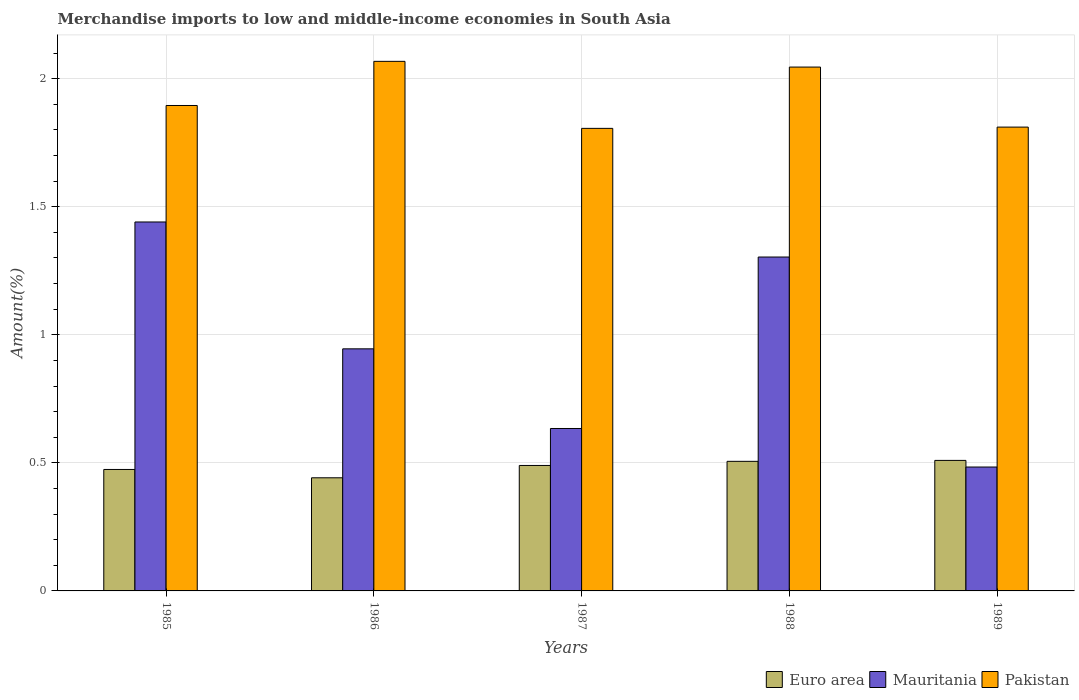How many groups of bars are there?
Make the answer very short. 5. Are the number of bars per tick equal to the number of legend labels?
Your response must be concise. Yes. Are the number of bars on each tick of the X-axis equal?
Keep it short and to the point. Yes. How many bars are there on the 5th tick from the left?
Provide a succinct answer. 3. How many bars are there on the 4th tick from the right?
Make the answer very short. 3. What is the label of the 1st group of bars from the left?
Your answer should be very brief. 1985. What is the percentage of amount earned from merchandise imports in Euro area in 1988?
Your answer should be very brief. 0.51. Across all years, what is the maximum percentage of amount earned from merchandise imports in Mauritania?
Offer a terse response. 1.44. Across all years, what is the minimum percentage of amount earned from merchandise imports in Euro area?
Ensure brevity in your answer.  0.44. In which year was the percentage of amount earned from merchandise imports in Mauritania minimum?
Provide a short and direct response. 1989. What is the total percentage of amount earned from merchandise imports in Euro area in the graph?
Provide a succinct answer. 2.42. What is the difference between the percentage of amount earned from merchandise imports in Mauritania in 1985 and that in 1986?
Your response must be concise. 0.5. What is the difference between the percentage of amount earned from merchandise imports in Pakistan in 1987 and the percentage of amount earned from merchandise imports in Mauritania in 1989?
Keep it short and to the point. 1.32. What is the average percentage of amount earned from merchandise imports in Pakistan per year?
Offer a very short reply. 1.93. In the year 1985, what is the difference between the percentage of amount earned from merchandise imports in Euro area and percentage of amount earned from merchandise imports in Mauritania?
Your answer should be very brief. -0.97. What is the ratio of the percentage of amount earned from merchandise imports in Pakistan in 1988 to that in 1989?
Offer a terse response. 1.13. What is the difference between the highest and the second highest percentage of amount earned from merchandise imports in Mauritania?
Provide a short and direct response. 0.14. What is the difference between the highest and the lowest percentage of amount earned from merchandise imports in Euro area?
Offer a very short reply. 0.07. What does the 3rd bar from the left in 1988 represents?
Ensure brevity in your answer.  Pakistan. Is it the case that in every year, the sum of the percentage of amount earned from merchandise imports in Euro area and percentage of amount earned from merchandise imports in Mauritania is greater than the percentage of amount earned from merchandise imports in Pakistan?
Offer a terse response. No. How many bars are there?
Your answer should be compact. 15. What is the difference between two consecutive major ticks on the Y-axis?
Give a very brief answer. 0.5. Are the values on the major ticks of Y-axis written in scientific E-notation?
Offer a terse response. No. Does the graph contain grids?
Your response must be concise. Yes. How are the legend labels stacked?
Keep it short and to the point. Horizontal. What is the title of the graph?
Provide a short and direct response. Merchandise imports to low and middle-income economies in South Asia. What is the label or title of the X-axis?
Your response must be concise. Years. What is the label or title of the Y-axis?
Provide a short and direct response. Amount(%). What is the Amount(%) of Euro area in 1985?
Keep it short and to the point. 0.47. What is the Amount(%) of Mauritania in 1985?
Provide a succinct answer. 1.44. What is the Amount(%) of Pakistan in 1985?
Keep it short and to the point. 1.9. What is the Amount(%) in Euro area in 1986?
Your answer should be compact. 0.44. What is the Amount(%) in Mauritania in 1986?
Keep it short and to the point. 0.95. What is the Amount(%) in Pakistan in 1986?
Offer a very short reply. 2.07. What is the Amount(%) of Euro area in 1987?
Provide a short and direct response. 0.49. What is the Amount(%) in Mauritania in 1987?
Your answer should be very brief. 0.63. What is the Amount(%) of Pakistan in 1987?
Offer a very short reply. 1.81. What is the Amount(%) of Euro area in 1988?
Make the answer very short. 0.51. What is the Amount(%) in Mauritania in 1988?
Your answer should be very brief. 1.3. What is the Amount(%) of Pakistan in 1988?
Provide a short and direct response. 2.05. What is the Amount(%) of Euro area in 1989?
Your answer should be very brief. 0.51. What is the Amount(%) of Mauritania in 1989?
Ensure brevity in your answer.  0.48. What is the Amount(%) in Pakistan in 1989?
Your answer should be very brief. 1.81. Across all years, what is the maximum Amount(%) in Euro area?
Offer a very short reply. 0.51. Across all years, what is the maximum Amount(%) in Mauritania?
Give a very brief answer. 1.44. Across all years, what is the maximum Amount(%) in Pakistan?
Give a very brief answer. 2.07. Across all years, what is the minimum Amount(%) in Euro area?
Your answer should be very brief. 0.44. Across all years, what is the minimum Amount(%) of Mauritania?
Offer a very short reply. 0.48. Across all years, what is the minimum Amount(%) of Pakistan?
Offer a very short reply. 1.81. What is the total Amount(%) of Euro area in the graph?
Give a very brief answer. 2.42. What is the total Amount(%) in Mauritania in the graph?
Offer a very short reply. 4.81. What is the total Amount(%) in Pakistan in the graph?
Keep it short and to the point. 9.63. What is the difference between the Amount(%) of Euro area in 1985 and that in 1986?
Provide a succinct answer. 0.03. What is the difference between the Amount(%) in Mauritania in 1985 and that in 1986?
Your answer should be compact. 0.5. What is the difference between the Amount(%) in Pakistan in 1985 and that in 1986?
Make the answer very short. -0.17. What is the difference between the Amount(%) in Euro area in 1985 and that in 1987?
Provide a short and direct response. -0.02. What is the difference between the Amount(%) of Mauritania in 1985 and that in 1987?
Offer a terse response. 0.81. What is the difference between the Amount(%) in Pakistan in 1985 and that in 1987?
Your answer should be very brief. 0.09. What is the difference between the Amount(%) in Euro area in 1985 and that in 1988?
Keep it short and to the point. -0.03. What is the difference between the Amount(%) of Mauritania in 1985 and that in 1988?
Provide a short and direct response. 0.14. What is the difference between the Amount(%) of Euro area in 1985 and that in 1989?
Offer a very short reply. -0.04. What is the difference between the Amount(%) of Mauritania in 1985 and that in 1989?
Make the answer very short. 0.96. What is the difference between the Amount(%) in Pakistan in 1985 and that in 1989?
Your answer should be very brief. 0.08. What is the difference between the Amount(%) of Euro area in 1986 and that in 1987?
Give a very brief answer. -0.05. What is the difference between the Amount(%) in Mauritania in 1986 and that in 1987?
Keep it short and to the point. 0.31. What is the difference between the Amount(%) of Pakistan in 1986 and that in 1987?
Provide a succinct answer. 0.26. What is the difference between the Amount(%) of Euro area in 1986 and that in 1988?
Provide a succinct answer. -0.06. What is the difference between the Amount(%) of Mauritania in 1986 and that in 1988?
Give a very brief answer. -0.36. What is the difference between the Amount(%) in Pakistan in 1986 and that in 1988?
Keep it short and to the point. 0.02. What is the difference between the Amount(%) in Euro area in 1986 and that in 1989?
Offer a very short reply. -0.07. What is the difference between the Amount(%) of Mauritania in 1986 and that in 1989?
Ensure brevity in your answer.  0.46. What is the difference between the Amount(%) of Pakistan in 1986 and that in 1989?
Keep it short and to the point. 0.26. What is the difference between the Amount(%) of Euro area in 1987 and that in 1988?
Provide a succinct answer. -0.02. What is the difference between the Amount(%) in Mauritania in 1987 and that in 1988?
Keep it short and to the point. -0.67. What is the difference between the Amount(%) of Pakistan in 1987 and that in 1988?
Give a very brief answer. -0.24. What is the difference between the Amount(%) in Euro area in 1987 and that in 1989?
Keep it short and to the point. -0.02. What is the difference between the Amount(%) in Mauritania in 1987 and that in 1989?
Your answer should be compact. 0.15. What is the difference between the Amount(%) in Pakistan in 1987 and that in 1989?
Ensure brevity in your answer.  -0. What is the difference between the Amount(%) in Euro area in 1988 and that in 1989?
Offer a very short reply. -0. What is the difference between the Amount(%) in Mauritania in 1988 and that in 1989?
Your answer should be very brief. 0.82. What is the difference between the Amount(%) in Pakistan in 1988 and that in 1989?
Your answer should be compact. 0.23. What is the difference between the Amount(%) of Euro area in 1985 and the Amount(%) of Mauritania in 1986?
Ensure brevity in your answer.  -0.47. What is the difference between the Amount(%) in Euro area in 1985 and the Amount(%) in Pakistan in 1986?
Keep it short and to the point. -1.59. What is the difference between the Amount(%) in Mauritania in 1985 and the Amount(%) in Pakistan in 1986?
Offer a very short reply. -0.63. What is the difference between the Amount(%) in Euro area in 1985 and the Amount(%) in Mauritania in 1987?
Offer a terse response. -0.16. What is the difference between the Amount(%) of Euro area in 1985 and the Amount(%) of Pakistan in 1987?
Give a very brief answer. -1.33. What is the difference between the Amount(%) in Mauritania in 1985 and the Amount(%) in Pakistan in 1987?
Make the answer very short. -0.37. What is the difference between the Amount(%) of Euro area in 1985 and the Amount(%) of Mauritania in 1988?
Your response must be concise. -0.83. What is the difference between the Amount(%) in Euro area in 1985 and the Amount(%) in Pakistan in 1988?
Give a very brief answer. -1.57. What is the difference between the Amount(%) in Mauritania in 1985 and the Amount(%) in Pakistan in 1988?
Provide a succinct answer. -0.6. What is the difference between the Amount(%) in Euro area in 1985 and the Amount(%) in Mauritania in 1989?
Give a very brief answer. -0.01. What is the difference between the Amount(%) of Euro area in 1985 and the Amount(%) of Pakistan in 1989?
Offer a very short reply. -1.34. What is the difference between the Amount(%) of Mauritania in 1985 and the Amount(%) of Pakistan in 1989?
Make the answer very short. -0.37. What is the difference between the Amount(%) of Euro area in 1986 and the Amount(%) of Mauritania in 1987?
Ensure brevity in your answer.  -0.19. What is the difference between the Amount(%) in Euro area in 1986 and the Amount(%) in Pakistan in 1987?
Keep it short and to the point. -1.36. What is the difference between the Amount(%) of Mauritania in 1986 and the Amount(%) of Pakistan in 1987?
Keep it short and to the point. -0.86. What is the difference between the Amount(%) in Euro area in 1986 and the Amount(%) in Mauritania in 1988?
Offer a terse response. -0.86. What is the difference between the Amount(%) in Euro area in 1986 and the Amount(%) in Pakistan in 1988?
Make the answer very short. -1.6. What is the difference between the Amount(%) of Mauritania in 1986 and the Amount(%) of Pakistan in 1988?
Make the answer very short. -1.1. What is the difference between the Amount(%) in Euro area in 1986 and the Amount(%) in Mauritania in 1989?
Provide a succinct answer. -0.04. What is the difference between the Amount(%) in Euro area in 1986 and the Amount(%) in Pakistan in 1989?
Provide a short and direct response. -1.37. What is the difference between the Amount(%) of Mauritania in 1986 and the Amount(%) of Pakistan in 1989?
Your answer should be compact. -0.87. What is the difference between the Amount(%) of Euro area in 1987 and the Amount(%) of Mauritania in 1988?
Ensure brevity in your answer.  -0.81. What is the difference between the Amount(%) in Euro area in 1987 and the Amount(%) in Pakistan in 1988?
Keep it short and to the point. -1.56. What is the difference between the Amount(%) in Mauritania in 1987 and the Amount(%) in Pakistan in 1988?
Keep it short and to the point. -1.41. What is the difference between the Amount(%) of Euro area in 1987 and the Amount(%) of Mauritania in 1989?
Your answer should be very brief. 0.01. What is the difference between the Amount(%) in Euro area in 1987 and the Amount(%) in Pakistan in 1989?
Offer a very short reply. -1.32. What is the difference between the Amount(%) of Mauritania in 1987 and the Amount(%) of Pakistan in 1989?
Provide a succinct answer. -1.18. What is the difference between the Amount(%) of Euro area in 1988 and the Amount(%) of Mauritania in 1989?
Offer a terse response. 0.02. What is the difference between the Amount(%) of Euro area in 1988 and the Amount(%) of Pakistan in 1989?
Provide a succinct answer. -1.3. What is the difference between the Amount(%) of Mauritania in 1988 and the Amount(%) of Pakistan in 1989?
Your answer should be very brief. -0.51. What is the average Amount(%) in Euro area per year?
Your answer should be very brief. 0.48. What is the average Amount(%) in Mauritania per year?
Your answer should be compact. 0.96. What is the average Amount(%) of Pakistan per year?
Your answer should be compact. 1.93. In the year 1985, what is the difference between the Amount(%) in Euro area and Amount(%) in Mauritania?
Offer a terse response. -0.97. In the year 1985, what is the difference between the Amount(%) of Euro area and Amount(%) of Pakistan?
Provide a short and direct response. -1.42. In the year 1985, what is the difference between the Amount(%) of Mauritania and Amount(%) of Pakistan?
Provide a short and direct response. -0.45. In the year 1986, what is the difference between the Amount(%) of Euro area and Amount(%) of Mauritania?
Make the answer very short. -0.5. In the year 1986, what is the difference between the Amount(%) in Euro area and Amount(%) in Pakistan?
Your answer should be compact. -1.63. In the year 1986, what is the difference between the Amount(%) in Mauritania and Amount(%) in Pakistan?
Give a very brief answer. -1.12. In the year 1987, what is the difference between the Amount(%) in Euro area and Amount(%) in Mauritania?
Offer a terse response. -0.14. In the year 1987, what is the difference between the Amount(%) in Euro area and Amount(%) in Pakistan?
Ensure brevity in your answer.  -1.32. In the year 1987, what is the difference between the Amount(%) in Mauritania and Amount(%) in Pakistan?
Keep it short and to the point. -1.17. In the year 1988, what is the difference between the Amount(%) of Euro area and Amount(%) of Mauritania?
Your answer should be very brief. -0.8. In the year 1988, what is the difference between the Amount(%) in Euro area and Amount(%) in Pakistan?
Ensure brevity in your answer.  -1.54. In the year 1988, what is the difference between the Amount(%) in Mauritania and Amount(%) in Pakistan?
Keep it short and to the point. -0.74. In the year 1989, what is the difference between the Amount(%) in Euro area and Amount(%) in Mauritania?
Make the answer very short. 0.03. In the year 1989, what is the difference between the Amount(%) of Euro area and Amount(%) of Pakistan?
Provide a succinct answer. -1.3. In the year 1989, what is the difference between the Amount(%) in Mauritania and Amount(%) in Pakistan?
Your answer should be very brief. -1.33. What is the ratio of the Amount(%) in Euro area in 1985 to that in 1986?
Offer a terse response. 1.07. What is the ratio of the Amount(%) in Mauritania in 1985 to that in 1986?
Keep it short and to the point. 1.52. What is the ratio of the Amount(%) of Pakistan in 1985 to that in 1986?
Offer a very short reply. 0.92. What is the ratio of the Amount(%) of Euro area in 1985 to that in 1987?
Provide a succinct answer. 0.97. What is the ratio of the Amount(%) of Mauritania in 1985 to that in 1987?
Give a very brief answer. 2.27. What is the ratio of the Amount(%) of Pakistan in 1985 to that in 1987?
Keep it short and to the point. 1.05. What is the ratio of the Amount(%) in Euro area in 1985 to that in 1988?
Keep it short and to the point. 0.94. What is the ratio of the Amount(%) in Mauritania in 1985 to that in 1988?
Your answer should be compact. 1.1. What is the ratio of the Amount(%) in Pakistan in 1985 to that in 1988?
Your response must be concise. 0.93. What is the ratio of the Amount(%) in Euro area in 1985 to that in 1989?
Provide a succinct answer. 0.93. What is the ratio of the Amount(%) of Mauritania in 1985 to that in 1989?
Your answer should be compact. 2.98. What is the ratio of the Amount(%) of Pakistan in 1985 to that in 1989?
Keep it short and to the point. 1.05. What is the ratio of the Amount(%) in Euro area in 1986 to that in 1987?
Make the answer very short. 0.9. What is the ratio of the Amount(%) in Mauritania in 1986 to that in 1987?
Provide a succinct answer. 1.49. What is the ratio of the Amount(%) in Pakistan in 1986 to that in 1987?
Offer a terse response. 1.14. What is the ratio of the Amount(%) of Euro area in 1986 to that in 1988?
Your answer should be compact. 0.87. What is the ratio of the Amount(%) in Mauritania in 1986 to that in 1988?
Your answer should be very brief. 0.72. What is the ratio of the Amount(%) of Pakistan in 1986 to that in 1988?
Make the answer very short. 1.01. What is the ratio of the Amount(%) of Euro area in 1986 to that in 1989?
Give a very brief answer. 0.87. What is the ratio of the Amount(%) of Mauritania in 1986 to that in 1989?
Make the answer very short. 1.95. What is the ratio of the Amount(%) in Pakistan in 1986 to that in 1989?
Your answer should be very brief. 1.14. What is the ratio of the Amount(%) in Euro area in 1987 to that in 1988?
Your answer should be very brief. 0.97. What is the ratio of the Amount(%) in Mauritania in 1987 to that in 1988?
Provide a short and direct response. 0.49. What is the ratio of the Amount(%) in Pakistan in 1987 to that in 1988?
Provide a short and direct response. 0.88. What is the ratio of the Amount(%) in Euro area in 1987 to that in 1989?
Your answer should be very brief. 0.96. What is the ratio of the Amount(%) in Mauritania in 1987 to that in 1989?
Your response must be concise. 1.31. What is the ratio of the Amount(%) of Pakistan in 1987 to that in 1989?
Offer a terse response. 1. What is the ratio of the Amount(%) of Mauritania in 1988 to that in 1989?
Your answer should be very brief. 2.69. What is the ratio of the Amount(%) in Pakistan in 1988 to that in 1989?
Ensure brevity in your answer.  1.13. What is the difference between the highest and the second highest Amount(%) of Euro area?
Offer a terse response. 0. What is the difference between the highest and the second highest Amount(%) of Mauritania?
Your answer should be compact. 0.14. What is the difference between the highest and the second highest Amount(%) of Pakistan?
Offer a very short reply. 0.02. What is the difference between the highest and the lowest Amount(%) of Euro area?
Keep it short and to the point. 0.07. What is the difference between the highest and the lowest Amount(%) in Mauritania?
Keep it short and to the point. 0.96. What is the difference between the highest and the lowest Amount(%) in Pakistan?
Make the answer very short. 0.26. 